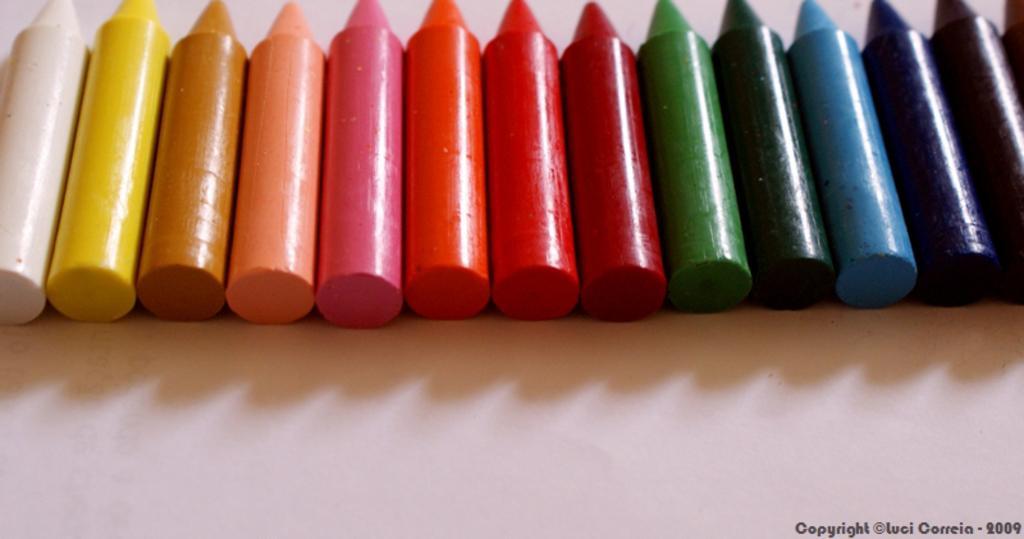Can you describe this image briefly? In this image there are crayons. There is some text on the right side of the image. 